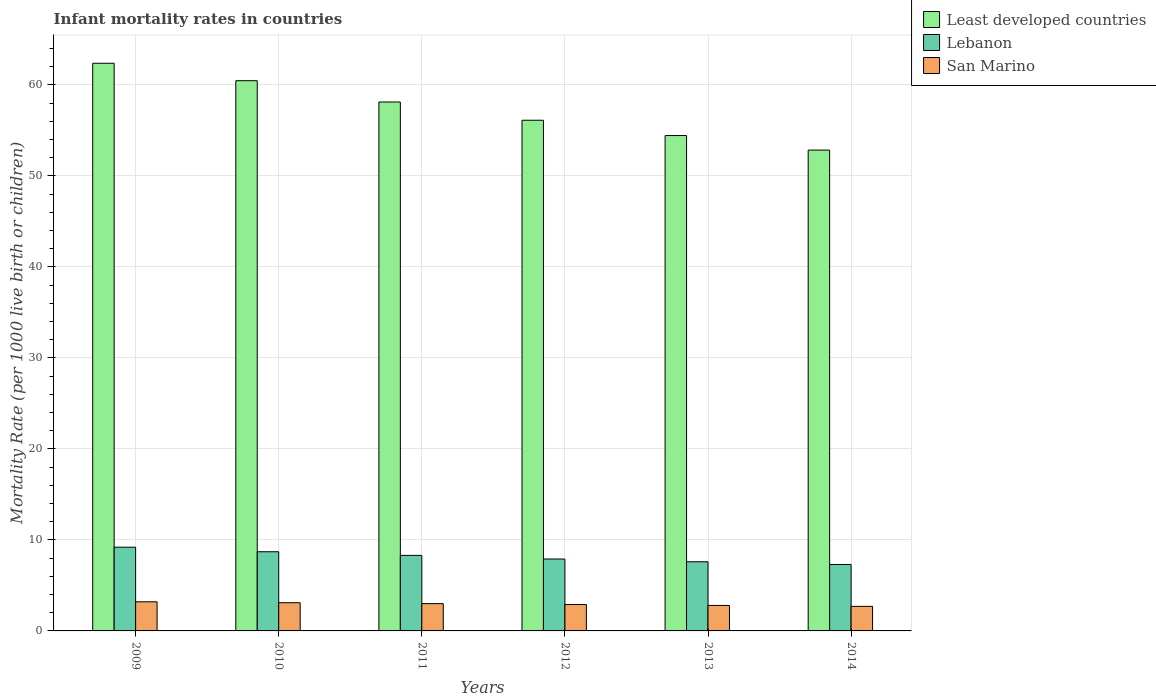How many bars are there on the 5th tick from the left?
Offer a very short reply. 3. What is the label of the 1st group of bars from the left?
Give a very brief answer. 2009. In how many cases, is the number of bars for a given year not equal to the number of legend labels?
Ensure brevity in your answer.  0. What is the infant mortality rate in Least developed countries in 2010?
Your answer should be very brief. 60.46. Across all years, what is the minimum infant mortality rate in San Marino?
Offer a terse response. 2.7. In which year was the infant mortality rate in Lebanon maximum?
Your response must be concise. 2009. What is the difference between the infant mortality rate in Lebanon in 2009 and that in 2010?
Your answer should be very brief. 0.5. What is the difference between the infant mortality rate in San Marino in 2014 and the infant mortality rate in Least developed countries in 2012?
Offer a terse response. -53.41. What is the average infant mortality rate in Least developed countries per year?
Offer a terse response. 57.39. In the year 2014, what is the difference between the infant mortality rate in Least developed countries and infant mortality rate in San Marino?
Your answer should be compact. 50.13. What is the ratio of the infant mortality rate in San Marino in 2010 to that in 2013?
Your answer should be compact. 1.11. Is the infant mortality rate in Lebanon in 2009 less than that in 2010?
Offer a terse response. No. What is the difference between the highest and the second highest infant mortality rate in Least developed countries?
Your response must be concise. 1.92. What is the difference between the highest and the lowest infant mortality rate in Least developed countries?
Your response must be concise. 9.54. Is the sum of the infant mortality rate in Least developed countries in 2009 and 2014 greater than the maximum infant mortality rate in Lebanon across all years?
Provide a succinct answer. Yes. What does the 3rd bar from the left in 2009 represents?
Provide a succinct answer. San Marino. What does the 1st bar from the right in 2014 represents?
Keep it short and to the point. San Marino. How many bars are there?
Offer a terse response. 18. Are all the bars in the graph horizontal?
Your answer should be compact. No. How many years are there in the graph?
Ensure brevity in your answer.  6. Are the values on the major ticks of Y-axis written in scientific E-notation?
Ensure brevity in your answer.  No. Does the graph contain any zero values?
Make the answer very short. No. Where does the legend appear in the graph?
Your answer should be compact. Top right. How many legend labels are there?
Your response must be concise. 3. What is the title of the graph?
Your answer should be very brief. Infant mortality rates in countries. What is the label or title of the Y-axis?
Your response must be concise. Mortality Rate (per 1000 live birth or children). What is the Mortality Rate (per 1000 live birth or children) in Least developed countries in 2009?
Provide a short and direct response. 62.37. What is the Mortality Rate (per 1000 live birth or children) of Lebanon in 2009?
Provide a short and direct response. 9.2. What is the Mortality Rate (per 1000 live birth or children) of San Marino in 2009?
Provide a short and direct response. 3.2. What is the Mortality Rate (per 1000 live birth or children) of Least developed countries in 2010?
Provide a succinct answer. 60.46. What is the Mortality Rate (per 1000 live birth or children) of Least developed countries in 2011?
Your answer should be compact. 58.11. What is the Mortality Rate (per 1000 live birth or children) in San Marino in 2011?
Your answer should be compact. 3. What is the Mortality Rate (per 1000 live birth or children) in Least developed countries in 2012?
Your answer should be very brief. 56.11. What is the Mortality Rate (per 1000 live birth or children) in Least developed countries in 2013?
Offer a very short reply. 54.43. What is the Mortality Rate (per 1000 live birth or children) in Least developed countries in 2014?
Your answer should be very brief. 52.83. Across all years, what is the maximum Mortality Rate (per 1000 live birth or children) of Least developed countries?
Give a very brief answer. 62.37. Across all years, what is the minimum Mortality Rate (per 1000 live birth or children) in Least developed countries?
Offer a terse response. 52.83. Across all years, what is the minimum Mortality Rate (per 1000 live birth or children) in San Marino?
Your response must be concise. 2.7. What is the total Mortality Rate (per 1000 live birth or children) in Least developed countries in the graph?
Provide a short and direct response. 344.32. What is the total Mortality Rate (per 1000 live birth or children) of San Marino in the graph?
Your answer should be compact. 17.7. What is the difference between the Mortality Rate (per 1000 live birth or children) in Least developed countries in 2009 and that in 2010?
Offer a terse response. 1.92. What is the difference between the Mortality Rate (per 1000 live birth or children) of Lebanon in 2009 and that in 2010?
Your answer should be compact. 0.5. What is the difference between the Mortality Rate (per 1000 live birth or children) in Least developed countries in 2009 and that in 2011?
Provide a short and direct response. 4.26. What is the difference between the Mortality Rate (per 1000 live birth or children) of Least developed countries in 2009 and that in 2012?
Your response must be concise. 6.26. What is the difference between the Mortality Rate (per 1000 live birth or children) of Lebanon in 2009 and that in 2012?
Your answer should be compact. 1.3. What is the difference between the Mortality Rate (per 1000 live birth or children) in Least developed countries in 2009 and that in 2013?
Make the answer very short. 7.94. What is the difference between the Mortality Rate (per 1000 live birth or children) in Lebanon in 2009 and that in 2013?
Keep it short and to the point. 1.6. What is the difference between the Mortality Rate (per 1000 live birth or children) in Least developed countries in 2009 and that in 2014?
Give a very brief answer. 9.54. What is the difference between the Mortality Rate (per 1000 live birth or children) of Least developed countries in 2010 and that in 2011?
Make the answer very short. 2.34. What is the difference between the Mortality Rate (per 1000 live birth or children) of Lebanon in 2010 and that in 2011?
Your response must be concise. 0.4. What is the difference between the Mortality Rate (per 1000 live birth or children) in Least developed countries in 2010 and that in 2012?
Your answer should be compact. 4.35. What is the difference between the Mortality Rate (per 1000 live birth or children) of Least developed countries in 2010 and that in 2013?
Your response must be concise. 6.03. What is the difference between the Mortality Rate (per 1000 live birth or children) in San Marino in 2010 and that in 2013?
Give a very brief answer. 0.3. What is the difference between the Mortality Rate (per 1000 live birth or children) in Least developed countries in 2010 and that in 2014?
Make the answer very short. 7.63. What is the difference between the Mortality Rate (per 1000 live birth or children) of Lebanon in 2010 and that in 2014?
Your answer should be very brief. 1.4. What is the difference between the Mortality Rate (per 1000 live birth or children) in Least developed countries in 2011 and that in 2012?
Your answer should be compact. 2. What is the difference between the Mortality Rate (per 1000 live birth or children) in Lebanon in 2011 and that in 2012?
Keep it short and to the point. 0.4. What is the difference between the Mortality Rate (per 1000 live birth or children) of San Marino in 2011 and that in 2012?
Make the answer very short. 0.1. What is the difference between the Mortality Rate (per 1000 live birth or children) of Least developed countries in 2011 and that in 2013?
Ensure brevity in your answer.  3.68. What is the difference between the Mortality Rate (per 1000 live birth or children) in Least developed countries in 2011 and that in 2014?
Provide a succinct answer. 5.28. What is the difference between the Mortality Rate (per 1000 live birth or children) of Lebanon in 2011 and that in 2014?
Provide a succinct answer. 1. What is the difference between the Mortality Rate (per 1000 live birth or children) of San Marino in 2011 and that in 2014?
Keep it short and to the point. 0.3. What is the difference between the Mortality Rate (per 1000 live birth or children) of Least developed countries in 2012 and that in 2013?
Your answer should be very brief. 1.68. What is the difference between the Mortality Rate (per 1000 live birth or children) in Lebanon in 2012 and that in 2013?
Provide a short and direct response. 0.3. What is the difference between the Mortality Rate (per 1000 live birth or children) in Least developed countries in 2012 and that in 2014?
Give a very brief answer. 3.28. What is the difference between the Mortality Rate (per 1000 live birth or children) of San Marino in 2012 and that in 2014?
Provide a short and direct response. 0.2. What is the difference between the Mortality Rate (per 1000 live birth or children) of San Marino in 2013 and that in 2014?
Offer a very short reply. 0.1. What is the difference between the Mortality Rate (per 1000 live birth or children) in Least developed countries in 2009 and the Mortality Rate (per 1000 live birth or children) in Lebanon in 2010?
Your answer should be very brief. 53.67. What is the difference between the Mortality Rate (per 1000 live birth or children) of Least developed countries in 2009 and the Mortality Rate (per 1000 live birth or children) of San Marino in 2010?
Keep it short and to the point. 59.27. What is the difference between the Mortality Rate (per 1000 live birth or children) in Lebanon in 2009 and the Mortality Rate (per 1000 live birth or children) in San Marino in 2010?
Keep it short and to the point. 6.1. What is the difference between the Mortality Rate (per 1000 live birth or children) in Least developed countries in 2009 and the Mortality Rate (per 1000 live birth or children) in Lebanon in 2011?
Make the answer very short. 54.07. What is the difference between the Mortality Rate (per 1000 live birth or children) in Least developed countries in 2009 and the Mortality Rate (per 1000 live birth or children) in San Marino in 2011?
Your response must be concise. 59.37. What is the difference between the Mortality Rate (per 1000 live birth or children) of Lebanon in 2009 and the Mortality Rate (per 1000 live birth or children) of San Marino in 2011?
Provide a succinct answer. 6.2. What is the difference between the Mortality Rate (per 1000 live birth or children) in Least developed countries in 2009 and the Mortality Rate (per 1000 live birth or children) in Lebanon in 2012?
Provide a succinct answer. 54.47. What is the difference between the Mortality Rate (per 1000 live birth or children) in Least developed countries in 2009 and the Mortality Rate (per 1000 live birth or children) in San Marino in 2012?
Your response must be concise. 59.47. What is the difference between the Mortality Rate (per 1000 live birth or children) of Lebanon in 2009 and the Mortality Rate (per 1000 live birth or children) of San Marino in 2012?
Your response must be concise. 6.3. What is the difference between the Mortality Rate (per 1000 live birth or children) of Least developed countries in 2009 and the Mortality Rate (per 1000 live birth or children) of Lebanon in 2013?
Keep it short and to the point. 54.77. What is the difference between the Mortality Rate (per 1000 live birth or children) in Least developed countries in 2009 and the Mortality Rate (per 1000 live birth or children) in San Marino in 2013?
Offer a very short reply. 59.57. What is the difference between the Mortality Rate (per 1000 live birth or children) of Lebanon in 2009 and the Mortality Rate (per 1000 live birth or children) of San Marino in 2013?
Your answer should be very brief. 6.4. What is the difference between the Mortality Rate (per 1000 live birth or children) in Least developed countries in 2009 and the Mortality Rate (per 1000 live birth or children) in Lebanon in 2014?
Your answer should be very brief. 55.07. What is the difference between the Mortality Rate (per 1000 live birth or children) of Least developed countries in 2009 and the Mortality Rate (per 1000 live birth or children) of San Marino in 2014?
Make the answer very short. 59.67. What is the difference between the Mortality Rate (per 1000 live birth or children) in Least developed countries in 2010 and the Mortality Rate (per 1000 live birth or children) in Lebanon in 2011?
Offer a very short reply. 52.16. What is the difference between the Mortality Rate (per 1000 live birth or children) of Least developed countries in 2010 and the Mortality Rate (per 1000 live birth or children) of San Marino in 2011?
Your answer should be compact. 57.46. What is the difference between the Mortality Rate (per 1000 live birth or children) in Least developed countries in 2010 and the Mortality Rate (per 1000 live birth or children) in Lebanon in 2012?
Your response must be concise. 52.56. What is the difference between the Mortality Rate (per 1000 live birth or children) of Least developed countries in 2010 and the Mortality Rate (per 1000 live birth or children) of San Marino in 2012?
Make the answer very short. 57.56. What is the difference between the Mortality Rate (per 1000 live birth or children) of Least developed countries in 2010 and the Mortality Rate (per 1000 live birth or children) of Lebanon in 2013?
Offer a very short reply. 52.86. What is the difference between the Mortality Rate (per 1000 live birth or children) in Least developed countries in 2010 and the Mortality Rate (per 1000 live birth or children) in San Marino in 2013?
Ensure brevity in your answer.  57.66. What is the difference between the Mortality Rate (per 1000 live birth or children) in Lebanon in 2010 and the Mortality Rate (per 1000 live birth or children) in San Marino in 2013?
Ensure brevity in your answer.  5.9. What is the difference between the Mortality Rate (per 1000 live birth or children) of Least developed countries in 2010 and the Mortality Rate (per 1000 live birth or children) of Lebanon in 2014?
Make the answer very short. 53.16. What is the difference between the Mortality Rate (per 1000 live birth or children) of Least developed countries in 2010 and the Mortality Rate (per 1000 live birth or children) of San Marino in 2014?
Offer a very short reply. 57.76. What is the difference between the Mortality Rate (per 1000 live birth or children) of Least developed countries in 2011 and the Mortality Rate (per 1000 live birth or children) of Lebanon in 2012?
Give a very brief answer. 50.21. What is the difference between the Mortality Rate (per 1000 live birth or children) in Least developed countries in 2011 and the Mortality Rate (per 1000 live birth or children) in San Marino in 2012?
Ensure brevity in your answer.  55.21. What is the difference between the Mortality Rate (per 1000 live birth or children) in Lebanon in 2011 and the Mortality Rate (per 1000 live birth or children) in San Marino in 2012?
Your answer should be compact. 5.4. What is the difference between the Mortality Rate (per 1000 live birth or children) in Least developed countries in 2011 and the Mortality Rate (per 1000 live birth or children) in Lebanon in 2013?
Ensure brevity in your answer.  50.51. What is the difference between the Mortality Rate (per 1000 live birth or children) in Least developed countries in 2011 and the Mortality Rate (per 1000 live birth or children) in San Marino in 2013?
Your answer should be very brief. 55.31. What is the difference between the Mortality Rate (per 1000 live birth or children) of Lebanon in 2011 and the Mortality Rate (per 1000 live birth or children) of San Marino in 2013?
Provide a succinct answer. 5.5. What is the difference between the Mortality Rate (per 1000 live birth or children) in Least developed countries in 2011 and the Mortality Rate (per 1000 live birth or children) in Lebanon in 2014?
Offer a terse response. 50.81. What is the difference between the Mortality Rate (per 1000 live birth or children) in Least developed countries in 2011 and the Mortality Rate (per 1000 live birth or children) in San Marino in 2014?
Provide a short and direct response. 55.41. What is the difference between the Mortality Rate (per 1000 live birth or children) in Lebanon in 2011 and the Mortality Rate (per 1000 live birth or children) in San Marino in 2014?
Provide a succinct answer. 5.6. What is the difference between the Mortality Rate (per 1000 live birth or children) of Least developed countries in 2012 and the Mortality Rate (per 1000 live birth or children) of Lebanon in 2013?
Your answer should be compact. 48.51. What is the difference between the Mortality Rate (per 1000 live birth or children) of Least developed countries in 2012 and the Mortality Rate (per 1000 live birth or children) of San Marino in 2013?
Your response must be concise. 53.31. What is the difference between the Mortality Rate (per 1000 live birth or children) in Lebanon in 2012 and the Mortality Rate (per 1000 live birth or children) in San Marino in 2013?
Provide a succinct answer. 5.1. What is the difference between the Mortality Rate (per 1000 live birth or children) in Least developed countries in 2012 and the Mortality Rate (per 1000 live birth or children) in Lebanon in 2014?
Give a very brief answer. 48.81. What is the difference between the Mortality Rate (per 1000 live birth or children) of Least developed countries in 2012 and the Mortality Rate (per 1000 live birth or children) of San Marino in 2014?
Make the answer very short. 53.41. What is the difference between the Mortality Rate (per 1000 live birth or children) of Least developed countries in 2013 and the Mortality Rate (per 1000 live birth or children) of Lebanon in 2014?
Provide a short and direct response. 47.13. What is the difference between the Mortality Rate (per 1000 live birth or children) in Least developed countries in 2013 and the Mortality Rate (per 1000 live birth or children) in San Marino in 2014?
Keep it short and to the point. 51.73. What is the average Mortality Rate (per 1000 live birth or children) of Least developed countries per year?
Your response must be concise. 57.39. What is the average Mortality Rate (per 1000 live birth or children) of Lebanon per year?
Your answer should be very brief. 8.17. What is the average Mortality Rate (per 1000 live birth or children) of San Marino per year?
Your answer should be compact. 2.95. In the year 2009, what is the difference between the Mortality Rate (per 1000 live birth or children) of Least developed countries and Mortality Rate (per 1000 live birth or children) of Lebanon?
Offer a very short reply. 53.17. In the year 2009, what is the difference between the Mortality Rate (per 1000 live birth or children) in Least developed countries and Mortality Rate (per 1000 live birth or children) in San Marino?
Your response must be concise. 59.17. In the year 2009, what is the difference between the Mortality Rate (per 1000 live birth or children) in Lebanon and Mortality Rate (per 1000 live birth or children) in San Marino?
Make the answer very short. 6. In the year 2010, what is the difference between the Mortality Rate (per 1000 live birth or children) of Least developed countries and Mortality Rate (per 1000 live birth or children) of Lebanon?
Offer a very short reply. 51.76. In the year 2010, what is the difference between the Mortality Rate (per 1000 live birth or children) in Least developed countries and Mortality Rate (per 1000 live birth or children) in San Marino?
Your answer should be compact. 57.36. In the year 2010, what is the difference between the Mortality Rate (per 1000 live birth or children) of Lebanon and Mortality Rate (per 1000 live birth or children) of San Marino?
Provide a succinct answer. 5.6. In the year 2011, what is the difference between the Mortality Rate (per 1000 live birth or children) in Least developed countries and Mortality Rate (per 1000 live birth or children) in Lebanon?
Offer a terse response. 49.81. In the year 2011, what is the difference between the Mortality Rate (per 1000 live birth or children) in Least developed countries and Mortality Rate (per 1000 live birth or children) in San Marino?
Offer a terse response. 55.11. In the year 2011, what is the difference between the Mortality Rate (per 1000 live birth or children) in Lebanon and Mortality Rate (per 1000 live birth or children) in San Marino?
Offer a terse response. 5.3. In the year 2012, what is the difference between the Mortality Rate (per 1000 live birth or children) of Least developed countries and Mortality Rate (per 1000 live birth or children) of Lebanon?
Your answer should be very brief. 48.21. In the year 2012, what is the difference between the Mortality Rate (per 1000 live birth or children) in Least developed countries and Mortality Rate (per 1000 live birth or children) in San Marino?
Keep it short and to the point. 53.21. In the year 2012, what is the difference between the Mortality Rate (per 1000 live birth or children) in Lebanon and Mortality Rate (per 1000 live birth or children) in San Marino?
Your answer should be compact. 5. In the year 2013, what is the difference between the Mortality Rate (per 1000 live birth or children) in Least developed countries and Mortality Rate (per 1000 live birth or children) in Lebanon?
Keep it short and to the point. 46.83. In the year 2013, what is the difference between the Mortality Rate (per 1000 live birth or children) in Least developed countries and Mortality Rate (per 1000 live birth or children) in San Marino?
Make the answer very short. 51.63. In the year 2014, what is the difference between the Mortality Rate (per 1000 live birth or children) in Least developed countries and Mortality Rate (per 1000 live birth or children) in Lebanon?
Your response must be concise. 45.53. In the year 2014, what is the difference between the Mortality Rate (per 1000 live birth or children) in Least developed countries and Mortality Rate (per 1000 live birth or children) in San Marino?
Offer a very short reply. 50.13. In the year 2014, what is the difference between the Mortality Rate (per 1000 live birth or children) of Lebanon and Mortality Rate (per 1000 live birth or children) of San Marino?
Your answer should be very brief. 4.6. What is the ratio of the Mortality Rate (per 1000 live birth or children) of Least developed countries in 2009 to that in 2010?
Your answer should be very brief. 1.03. What is the ratio of the Mortality Rate (per 1000 live birth or children) in Lebanon in 2009 to that in 2010?
Ensure brevity in your answer.  1.06. What is the ratio of the Mortality Rate (per 1000 live birth or children) of San Marino in 2009 to that in 2010?
Give a very brief answer. 1.03. What is the ratio of the Mortality Rate (per 1000 live birth or children) of Least developed countries in 2009 to that in 2011?
Ensure brevity in your answer.  1.07. What is the ratio of the Mortality Rate (per 1000 live birth or children) in Lebanon in 2009 to that in 2011?
Keep it short and to the point. 1.11. What is the ratio of the Mortality Rate (per 1000 live birth or children) in San Marino in 2009 to that in 2011?
Provide a short and direct response. 1.07. What is the ratio of the Mortality Rate (per 1000 live birth or children) of Least developed countries in 2009 to that in 2012?
Give a very brief answer. 1.11. What is the ratio of the Mortality Rate (per 1000 live birth or children) in Lebanon in 2009 to that in 2012?
Provide a short and direct response. 1.16. What is the ratio of the Mortality Rate (per 1000 live birth or children) of San Marino in 2009 to that in 2012?
Your response must be concise. 1.1. What is the ratio of the Mortality Rate (per 1000 live birth or children) in Least developed countries in 2009 to that in 2013?
Ensure brevity in your answer.  1.15. What is the ratio of the Mortality Rate (per 1000 live birth or children) in Lebanon in 2009 to that in 2013?
Your response must be concise. 1.21. What is the ratio of the Mortality Rate (per 1000 live birth or children) in San Marino in 2009 to that in 2013?
Offer a terse response. 1.14. What is the ratio of the Mortality Rate (per 1000 live birth or children) of Least developed countries in 2009 to that in 2014?
Make the answer very short. 1.18. What is the ratio of the Mortality Rate (per 1000 live birth or children) of Lebanon in 2009 to that in 2014?
Your response must be concise. 1.26. What is the ratio of the Mortality Rate (per 1000 live birth or children) of San Marino in 2009 to that in 2014?
Keep it short and to the point. 1.19. What is the ratio of the Mortality Rate (per 1000 live birth or children) in Least developed countries in 2010 to that in 2011?
Your answer should be very brief. 1.04. What is the ratio of the Mortality Rate (per 1000 live birth or children) in Lebanon in 2010 to that in 2011?
Your answer should be very brief. 1.05. What is the ratio of the Mortality Rate (per 1000 live birth or children) of San Marino in 2010 to that in 2011?
Keep it short and to the point. 1.03. What is the ratio of the Mortality Rate (per 1000 live birth or children) in Least developed countries in 2010 to that in 2012?
Your response must be concise. 1.08. What is the ratio of the Mortality Rate (per 1000 live birth or children) in Lebanon in 2010 to that in 2012?
Provide a short and direct response. 1.1. What is the ratio of the Mortality Rate (per 1000 live birth or children) of San Marino in 2010 to that in 2012?
Your answer should be compact. 1.07. What is the ratio of the Mortality Rate (per 1000 live birth or children) of Least developed countries in 2010 to that in 2013?
Your response must be concise. 1.11. What is the ratio of the Mortality Rate (per 1000 live birth or children) in Lebanon in 2010 to that in 2013?
Offer a terse response. 1.14. What is the ratio of the Mortality Rate (per 1000 live birth or children) of San Marino in 2010 to that in 2013?
Make the answer very short. 1.11. What is the ratio of the Mortality Rate (per 1000 live birth or children) of Least developed countries in 2010 to that in 2014?
Make the answer very short. 1.14. What is the ratio of the Mortality Rate (per 1000 live birth or children) of Lebanon in 2010 to that in 2014?
Provide a short and direct response. 1.19. What is the ratio of the Mortality Rate (per 1000 live birth or children) of San Marino in 2010 to that in 2014?
Your response must be concise. 1.15. What is the ratio of the Mortality Rate (per 1000 live birth or children) of Least developed countries in 2011 to that in 2012?
Keep it short and to the point. 1.04. What is the ratio of the Mortality Rate (per 1000 live birth or children) in Lebanon in 2011 to that in 2012?
Offer a very short reply. 1.05. What is the ratio of the Mortality Rate (per 1000 live birth or children) in San Marino in 2011 to that in 2012?
Make the answer very short. 1.03. What is the ratio of the Mortality Rate (per 1000 live birth or children) of Least developed countries in 2011 to that in 2013?
Provide a succinct answer. 1.07. What is the ratio of the Mortality Rate (per 1000 live birth or children) in Lebanon in 2011 to that in 2013?
Make the answer very short. 1.09. What is the ratio of the Mortality Rate (per 1000 live birth or children) of San Marino in 2011 to that in 2013?
Provide a short and direct response. 1.07. What is the ratio of the Mortality Rate (per 1000 live birth or children) of Lebanon in 2011 to that in 2014?
Offer a very short reply. 1.14. What is the ratio of the Mortality Rate (per 1000 live birth or children) in Least developed countries in 2012 to that in 2013?
Give a very brief answer. 1.03. What is the ratio of the Mortality Rate (per 1000 live birth or children) in Lebanon in 2012 to that in 2013?
Offer a terse response. 1.04. What is the ratio of the Mortality Rate (per 1000 live birth or children) of San Marino in 2012 to that in 2013?
Offer a terse response. 1.04. What is the ratio of the Mortality Rate (per 1000 live birth or children) of Least developed countries in 2012 to that in 2014?
Provide a succinct answer. 1.06. What is the ratio of the Mortality Rate (per 1000 live birth or children) of Lebanon in 2012 to that in 2014?
Provide a succinct answer. 1.08. What is the ratio of the Mortality Rate (per 1000 live birth or children) in San Marino in 2012 to that in 2014?
Keep it short and to the point. 1.07. What is the ratio of the Mortality Rate (per 1000 live birth or children) of Least developed countries in 2013 to that in 2014?
Provide a short and direct response. 1.03. What is the ratio of the Mortality Rate (per 1000 live birth or children) of Lebanon in 2013 to that in 2014?
Your response must be concise. 1.04. What is the difference between the highest and the second highest Mortality Rate (per 1000 live birth or children) of Least developed countries?
Give a very brief answer. 1.92. What is the difference between the highest and the lowest Mortality Rate (per 1000 live birth or children) of Least developed countries?
Offer a very short reply. 9.54. What is the difference between the highest and the lowest Mortality Rate (per 1000 live birth or children) in Lebanon?
Provide a succinct answer. 1.9. 